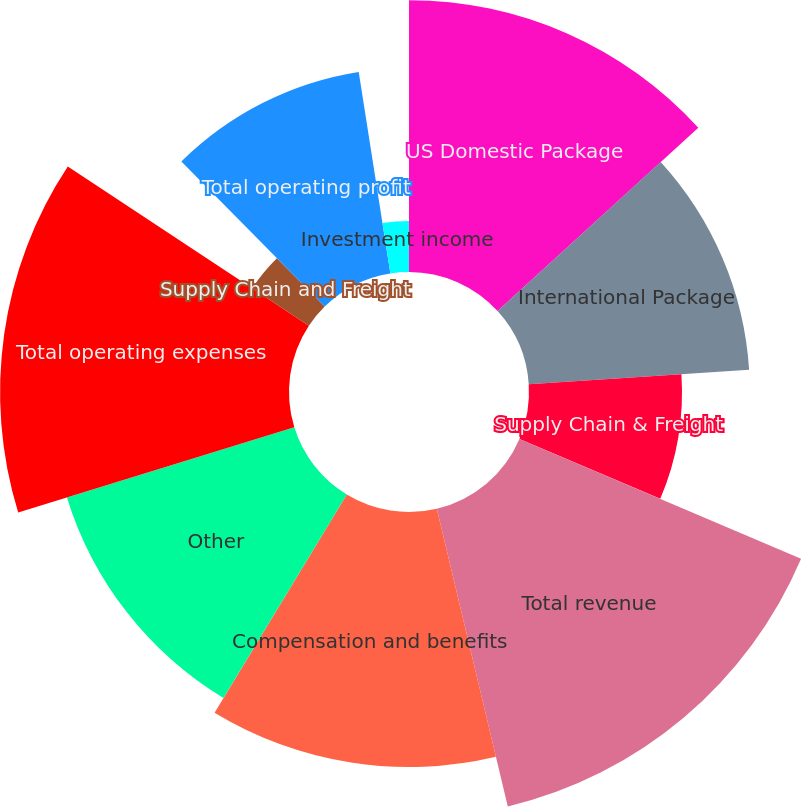Convert chart to OTSL. <chart><loc_0><loc_0><loc_500><loc_500><pie_chart><fcel>US Domestic Package<fcel>International Package<fcel>Supply Chain & Freight<fcel>Total revenue<fcel>Compensation and benefits<fcel>Other<fcel>Total operating expenses<fcel>Supply Chain and Freight<fcel>Total operating profit<fcel>Investment income<nl><fcel>13.22%<fcel>10.74%<fcel>7.44%<fcel>14.88%<fcel>12.4%<fcel>11.57%<fcel>14.05%<fcel>3.31%<fcel>9.92%<fcel>2.48%<nl></chart> 